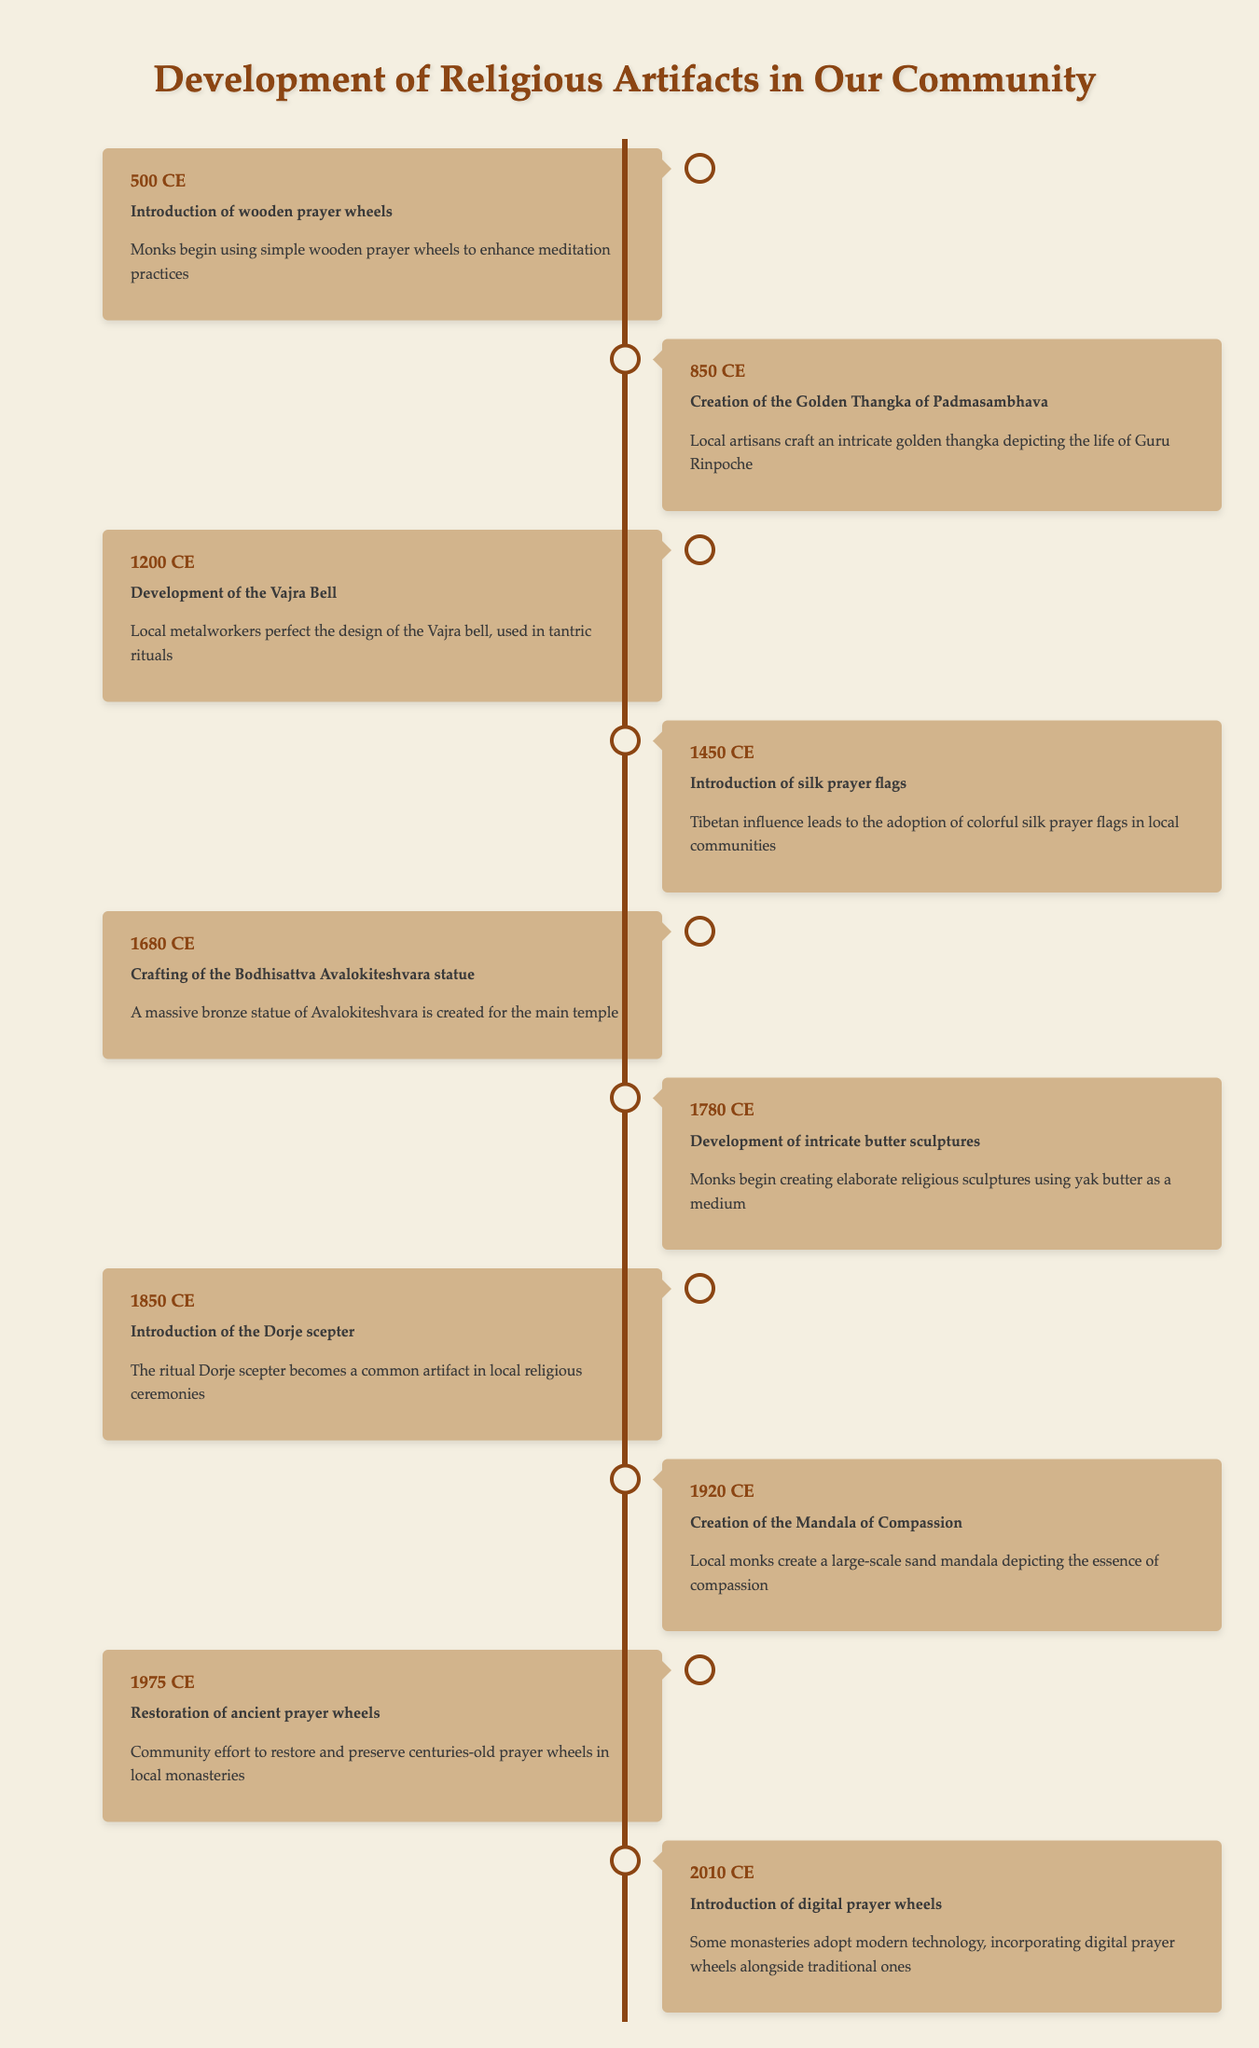What year did the introduction of the Dorje scepter occur? Looking at the timeline, the entry for the introduction of the Dorje scepter states it occurred in the year 1850.
Answer: 1850 What event is listed for the year 1450? According to the table, the event listed for the year 1450 is the introduction of silk prayer flags.
Answer: Introduction of silk prayer flags Is the creation of the Mandala of Compassion earlier or later than the crafting of the Bodhisattva Avalokiteshvara statue? The Mandala of Compassion was created in 1920, while the Bodhisattva Avalokiteshvara statue was crafted in 1680. Since 1680 is earlier than 1920, the statue was created before the mandala.
Answer: Earlier Which two events were focused on the use of new materials in religious artifacts? The timeline shows the introduction of silk prayer flags in 1450 and the development of intricate butter sculptures in 1780. Both events emphasize the use of new materials—silk and yak butter—respectively.
Answer: Introduction of silk prayer flags, Development of intricate butter sculptures How many years are there between the introduction of wooden prayer wheels and the crafting of the Bodhisattva Avalokiteshvara statue? The introduction of wooden prayer wheels occurred in 500, and the crafting of the statue occurred in 1680. To find the difference, subtract 500 from 1680, which results in 1180 years.
Answer: 1180 years True or False: The restoration of ancient prayer wheels happened in the same century as the introduction of digital prayer wheels. The restoration of ancient prayer wheels occurred in 1975 (20th century), and the introduction of digital prayer wheels occurred in 2010 (also 20th century). Therefore, this statement is true.
Answer: True Which event marks the first instance of using an artifact in a religious ceremony, and what is that artifact? The first instance mentioned in the timeline referring to an artifact in a religious ceremony is the introduction of wooden prayer wheels in 500. The wooden prayer wheel is the specified artifact.
Answer: Introduction of wooden prayer wheels What is the average year of the events from 500 to 1850? To find the average, take the years (500, 850, 1200, 1450, 1680, 1780, and 1850), add them up to get 11910, divide by 7 (the number of events) to get an average year of approximately 1701.43.
Answer: 1701 Has the crafting of the Vajra Bell become more common before or after 1450? The development of the Vajra Bell occurred in 1200, which is before the introduction of silk prayer flags in 1450. Hence, it became more common prior to that year.
Answer: Before 1450 